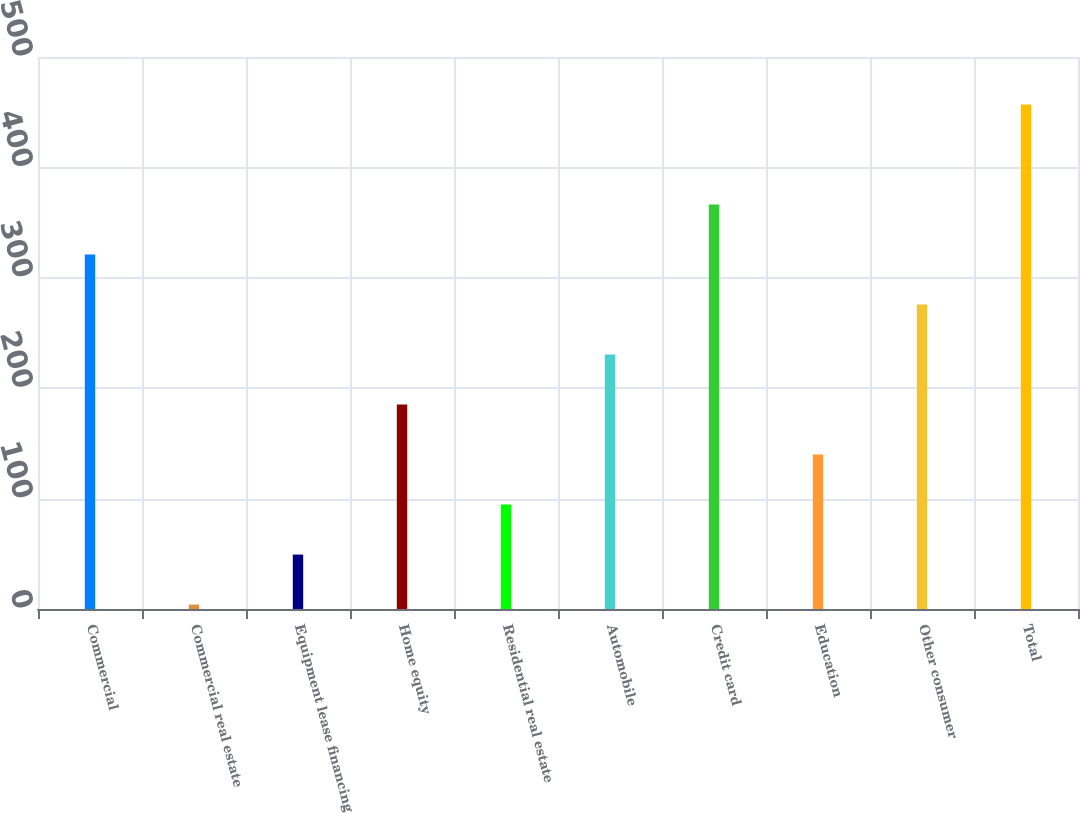<chart> <loc_0><loc_0><loc_500><loc_500><bar_chart><fcel>Commercial<fcel>Commercial real estate<fcel>Equipment lease financing<fcel>Home equity<fcel>Residential real estate<fcel>Automobile<fcel>Credit card<fcel>Education<fcel>Other consumer<fcel>Total<nl><fcel>321.1<fcel>4<fcel>49.3<fcel>185.2<fcel>94.6<fcel>230.5<fcel>366.4<fcel>139.9<fcel>275.8<fcel>457<nl></chart> 